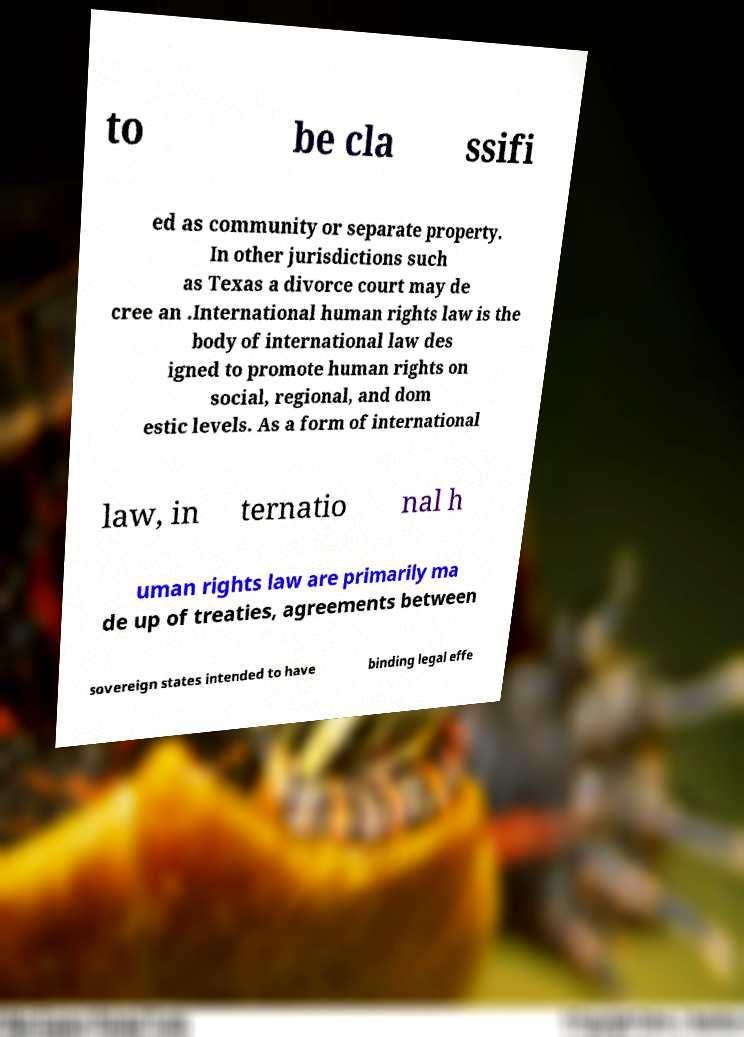Can you accurately transcribe the text from the provided image for me? to be cla ssifi ed as community or separate property. In other jurisdictions such as Texas a divorce court may de cree an .International human rights law is the body of international law des igned to promote human rights on social, regional, and dom estic levels. As a form of international law, in ternatio nal h uman rights law are primarily ma de up of treaties, agreements between sovereign states intended to have binding legal effe 